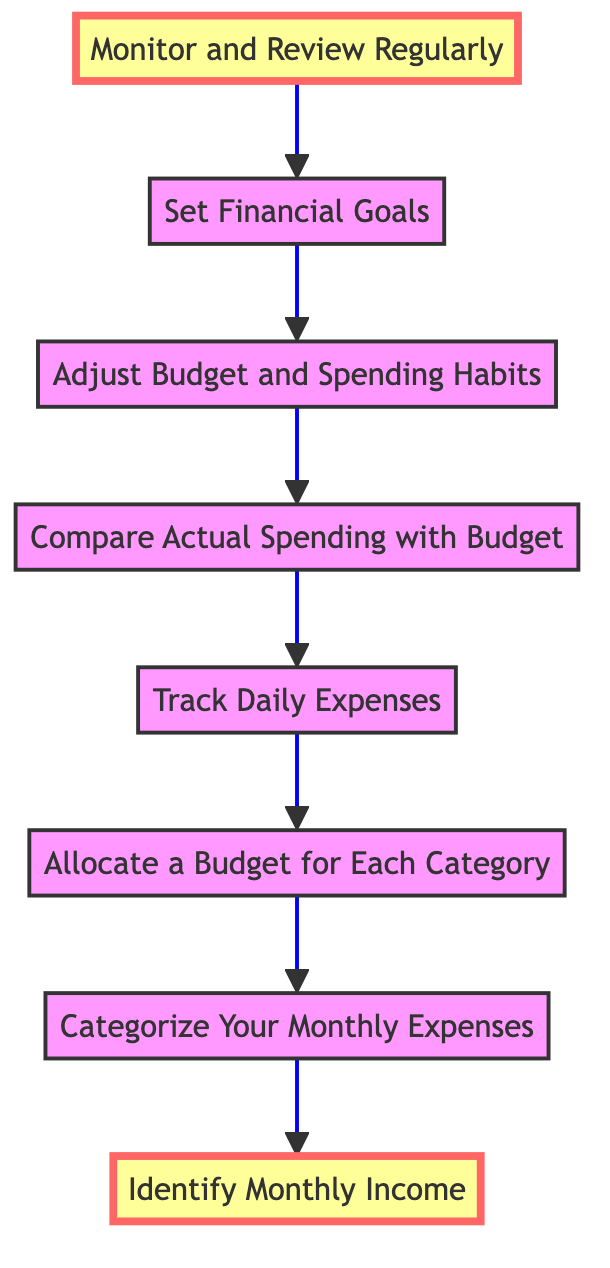What is the first step in the process? The diagram begins at the bottom with "Identify Monthly Income," which is the first action to take in managing monthly finances.
Answer: Identify Monthly Income How many total steps are there in the flowchart? By counting all nodes from "Identify Monthly Income" to "Monitor and Review Regularly," we find there are eight steps in total.
Answer: Eight What follows after "Set Financial Goals"? The next step in the flowchart that follows "Set Financial Goals" is "Monitor and Review Regularly."
Answer: Monitor and Review Regularly What is the last step in the process? The final action in the process, as indicated at the top of the flowchart, is "Monitor and Review Regularly."
Answer: Monitor and Review Regularly What step comes before "Adjust Budget and Spending Habits"? Prior to "Adjust Budget and Spending Habits," the step taken is "Compare Actual Spending with Budget."
Answer: Compare Actual Spending with Budget How does one track expenses according to the flowchart? According to the flowchart, expenses are tracked through the step labeled "Track Daily Expenses," which emphasizes recording daily expenditures.
Answer: Track Daily Expenses What actions are needed before setting financial goals? Before setting financial goals, the steps "Adjust Budget and Spending Habits" and "Compare Actual Spending with Budget" must be completed, indicating a focus on evaluating one's financial state prior to goal setting.
Answer: Adjust Budget and Spending Habits, Compare Actual Spending with Budget Does the flowchart indicate that monitoring finances is a continuous process? Yes, "Monitor and Review Regularly" at the end of the flowchart implies that monitoring is a regular activity in financial management.
Answer: Yes 